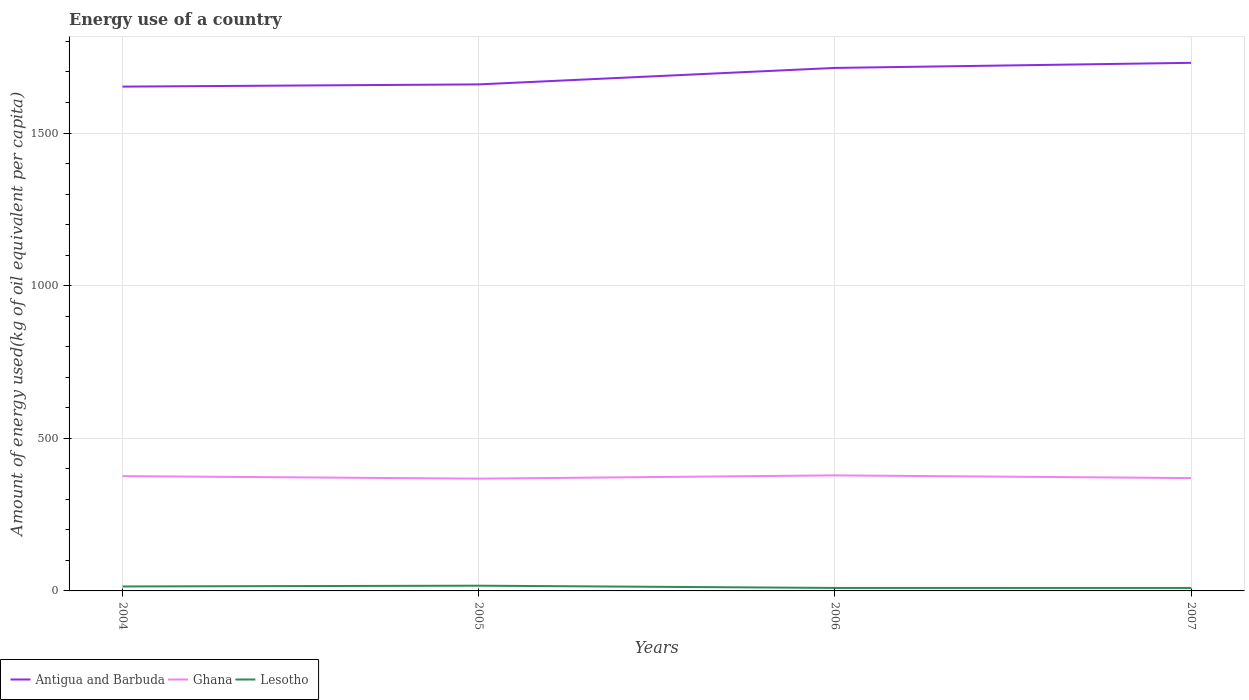Is the number of lines equal to the number of legend labels?
Your answer should be compact. Yes. Across all years, what is the maximum amount of energy used in in Ghana?
Provide a short and direct response. 367.76. What is the total amount of energy used in in Lesotho in the graph?
Your answer should be compact. 7.34. What is the difference between the highest and the second highest amount of energy used in in Antigua and Barbuda?
Make the answer very short. 77.9. How many lines are there?
Make the answer very short. 3. Does the graph contain any zero values?
Your answer should be very brief. No. How many legend labels are there?
Give a very brief answer. 3. What is the title of the graph?
Offer a very short reply. Energy use of a country. Does "Gabon" appear as one of the legend labels in the graph?
Your answer should be very brief. No. What is the label or title of the X-axis?
Offer a terse response. Years. What is the label or title of the Y-axis?
Ensure brevity in your answer.  Amount of energy used(kg of oil equivalent per capita). What is the Amount of energy used(kg of oil equivalent per capita) of Antigua and Barbuda in 2004?
Your response must be concise. 1652.02. What is the Amount of energy used(kg of oil equivalent per capita) of Ghana in 2004?
Offer a very short reply. 376.03. What is the Amount of energy used(kg of oil equivalent per capita) in Lesotho in 2004?
Provide a short and direct response. 14.64. What is the Amount of energy used(kg of oil equivalent per capita) in Antigua and Barbuda in 2005?
Keep it short and to the point. 1659.3. What is the Amount of energy used(kg of oil equivalent per capita) of Ghana in 2005?
Your answer should be compact. 367.76. What is the Amount of energy used(kg of oil equivalent per capita) of Lesotho in 2005?
Offer a terse response. 17.14. What is the Amount of energy used(kg of oil equivalent per capita) of Antigua and Barbuda in 2006?
Make the answer very short. 1713.25. What is the Amount of energy used(kg of oil equivalent per capita) of Ghana in 2006?
Make the answer very short. 378.49. What is the Amount of energy used(kg of oil equivalent per capita) in Lesotho in 2006?
Make the answer very short. 9.79. What is the Amount of energy used(kg of oil equivalent per capita) in Antigua and Barbuda in 2007?
Keep it short and to the point. 1729.92. What is the Amount of energy used(kg of oil equivalent per capita) in Ghana in 2007?
Ensure brevity in your answer.  369.66. What is the Amount of energy used(kg of oil equivalent per capita) in Lesotho in 2007?
Provide a succinct answer. 9.72. Across all years, what is the maximum Amount of energy used(kg of oil equivalent per capita) in Antigua and Barbuda?
Ensure brevity in your answer.  1729.92. Across all years, what is the maximum Amount of energy used(kg of oil equivalent per capita) of Ghana?
Keep it short and to the point. 378.49. Across all years, what is the maximum Amount of energy used(kg of oil equivalent per capita) of Lesotho?
Ensure brevity in your answer.  17.14. Across all years, what is the minimum Amount of energy used(kg of oil equivalent per capita) of Antigua and Barbuda?
Offer a very short reply. 1652.02. Across all years, what is the minimum Amount of energy used(kg of oil equivalent per capita) of Ghana?
Provide a short and direct response. 367.76. Across all years, what is the minimum Amount of energy used(kg of oil equivalent per capita) of Lesotho?
Your answer should be compact. 9.72. What is the total Amount of energy used(kg of oil equivalent per capita) in Antigua and Barbuda in the graph?
Ensure brevity in your answer.  6754.49. What is the total Amount of energy used(kg of oil equivalent per capita) in Ghana in the graph?
Offer a terse response. 1491.93. What is the total Amount of energy used(kg of oil equivalent per capita) of Lesotho in the graph?
Ensure brevity in your answer.  51.29. What is the difference between the Amount of energy used(kg of oil equivalent per capita) of Antigua and Barbuda in 2004 and that in 2005?
Give a very brief answer. -7.28. What is the difference between the Amount of energy used(kg of oil equivalent per capita) of Ghana in 2004 and that in 2005?
Offer a terse response. 8.27. What is the difference between the Amount of energy used(kg of oil equivalent per capita) of Lesotho in 2004 and that in 2005?
Offer a terse response. -2.49. What is the difference between the Amount of energy used(kg of oil equivalent per capita) of Antigua and Barbuda in 2004 and that in 2006?
Ensure brevity in your answer.  -61.23. What is the difference between the Amount of energy used(kg of oil equivalent per capita) of Ghana in 2004 and that in 2006?
Your answer should be compact. -2.46. What is the difference between the Amount of energy used(kg of oil equivalent per capita) of Lesotho in 2004 and that in 2006?
Provide a short and direct response. 4.85. What is the difference between the Amount of energy used(kg of oil equivalent per capita) of Antigua and Barbuda in 2004 and that in 2007?
Make the answer very short. -77.9. What is the difference between the Amount of energy used(kg of oil equivalent per capita) of Ghana in 2004 and that in 2007?
Ensure brevity in your answer.  6.37. What is the difference between the Amount of energy used(kg of oil equivalent per capita) of Lesotho in 2004 and that in 2007?
Ensure brevity in your answer.  4.93. What is the difference between the Amount of energy used(kg of oil equivalent per capita) in Antigua and Barbuda in 2005 and that in 2006?
Provide a short and direct response. -53.95. What is the difference between the Amount of energy used(kg of oil equivalent per capita) in Ghana in 2005 and that in 2006?
Give a very brief answer. -10.73. What is the difference between the Amount of energy used(kg of oil equivalent per capita) of Lesotho in 2005 and that in 2006?
Your answer should be compact. 7.34. What is the difference between the Amount of energy used(kg of oil equivalent per capita) in Antigua and Barbuda in 2005 and that in 2007?
Ensure brevity in your answer.  -70.62. What is the difference between the Amount of energy used(kg of oil equivalent per capita) of Ghana in 2005 and that in 2007?
Give a very brief answer. -1.9. What is the difference between the Amount of energy used(kg of oil equivalent per capita) in Lesotho in 2005 and that in 2007?
Give a very brief answer. 7.42. What is the difference between the Amount of energy used(kg of oil equivalent per capita) of Antigua and Barbuda in 2006 and that in 2007?
Offer a terse response. -16.67. What is the difference between the Amount of energy used(kg of oil equivalent per capita) of Ghana in 2006 and that in 2007?
Make the answer very short. 8.83. What is the difference between the Amount of energy used(kg of oil equivalent per capita) in Lesotho in 2006 and that in 2007?
Give a very brief answer. 0.08. What is the difference between the Amount of energy used(kg of oil equivalent per capita) of Antigua and Barbuda in 2004 and the Amount of energy used(kg of oil equivalent per capita) of Ghana in 2005?
Ensure brevity in your answer.  1284.27. What is the difference between the Amount of energy used(kg of oil equivalent per capita) of Antigua and Barbuda in 2004 and the Amount of energy used(kg of oil equivalent per capita) of Lesotho in 2005?
Make the answer very short. 1634.89. What is the difference between the Amount of energy used(kg of oil equivalent per capita) in Ghana in 2004 and the Amount of energy used(kg of oil equivalent per capita) in Lesotho in 2005?
Provide a succinct answer. 358.89. What is the difference between the Amount of energy used(kg of oil equivalent per capita) in Antigua and Barbuda in 2004 and the Amount of energy used(kg of oil equivalent per capita) in Ghana in 2006?
Your answer should be very brief. 1273.54. What is the difference between the Amount of energy used(kg of oil equivalent per capita) in Antigua and Barbuda in 2004 and the Amount of energy used(kg of oil equivalent per capita) in Lesotho in 2006?
Offer a terse response. 1642.23. What is the difference between the Amount of energy used(kg of oil equivalent per capita) of Ghana in 2004 and the Amount of energy used(kg of oil equivalent per capita) of Lesotho in 2006?
Provide a short and direct response. 366.24. What is the difference between the Amount of energy used(kg of oil equivalent per capita) of Antigua and Barbuda in 2004 and the Amount of energy used(kg of oil equivalent per capita) of Ghana in 2007?
Provide a short and direct response. 1282.37. What is the difference between the Amount of energy used(kg of oil equivalent per capita) in Antigua and Barbuda in 2004 and the Amount of energy used(kg of oil equivalent per capita) in Lesotho in 2007?
Provide a succinct answer. 1642.31. What is the difference between the Amount of energy used(kg of oil equivalent per capita) in Ghana in 2004 and the Amount of energy used(kg of oil equivalent per capita) in Lesotho in 2007?
Make the answer very short. 366.31. What is the difference between the Amount of energy used(kg of oil equivalent per capita) in Antigua and Barbuda in 2005 and the Amount of energy used(kg of oil equivalent per capita) in Ghana in 2006?
Provide a succinct answer. 1280.81. What is the difference between the Amount of energy used(kg of oil equivalent per capita) in Antigua and Barbuda in 2005 and the Amount of energy used(kg of oil equivalent per capita) in Lesotho in 2006?
Provide a short and direct response. 1649.51. What is the difference between the Amount of energy used(kg of oil equivalent per capita) of Ghana in 2005 and the Amount of energy used(kg of oil equivalent per capita) of Lesotho in 2006?
Your answer should be very brief. 357.97. What is the difference between the Amount of energy used(kg of oil equivalent per capita) of Antigua and Barbuda in 2005 and the Amount of energy used(kg of oil equivalent per capita) of Ghana in 2007?
Make the answer very short. 1289.64. What is the difference between the Amount of energy used(kg of oil equivalent per capita) of Antigua and Barbuda in 2005 and the Amount of energy used(kg of oil equivalent per capita) of Lesotho in 2007?
Offer a terse response. 1649.58. What is the difference between the Amount of energy used(kg of oil equivalent per capita) of Ghana in 2005 and the Amount of energy used(kg of oil equivalent per capita) of Lesotho in 2007?
Make the answer very short. 358.04. What is the difference between the Amount of energy used(kg of oil equivalent per capita) of Antigua and Barbuda in 2006 and the Amount of energy used(kg of oil equivalent per capita) of Ghana in 2007?
Give a very brief answer. 1343.59. What is the difference between the Amount of energy used(kg of oil equivalent per capita) of Antigua and Barbuda in 2006 and the Amount of energy used(kg of oil equivalent per capita) of Lesotho in 2007?
Your answer should be very brief. 1703.54. What is the difference between the Amount of energy used(kg of oil equivalent per capita) in Ghana in 2006 and the Amount of energy used(kg of oil equivalent per capita) in Lesotho in 2007?
Ensure brevity in your answer.  368.77. What is the average Amount of energy used(kg of oil equivalent per capita) of Antigua and Barbuda per year?
Keep it short and to the point. 1688.62. What is the average Amount of energy used(kg of oil equivalent per capita) in Ghana per year?
Offer a terse response. 372.98. What is the average Amount of energy used(kg of oil equivalent per capita) of Lesotho per year?
Give a very brief answer. 12.82. In the year 2004, what is the difference between the Amount of energy used(kg of oil equivalent per capita) of Antigua and Barbuda and Amount of energy used(kg of oil equivalent per capita) of Ghana?
Offer a very short reply. 1275.99. In the year 2004, what is the difference between the Amount of energy used(kg of oil equivalent per capita) in Antigua and Barbuda and Amount of energy used(kg of oil equivalent per capita) in Lesotho?
Give a very brief answer. 1637.38. In the year 2004, what is the difference between the Amount of energy used(kg of oil equivalent per capita) of Ghana and Amount of energy used(kg of oil equivalent per capita) of Lesotho?
Keep it short and to the point. 361.38. In the year 2005, what is the difference between the Amount of energy used(kg of oil equivalent per capita) in Antigua and Barbuda and Amount of energy used(kg of oil equivalent per capita) in Ghana?
Ensure brevity in your answer.  1291.54. In the year 2005, what is the difference between the Amount of energy used(kg of oil equivalent per capita) in Antigua and Barbuda and Amount of energy used(kg of oil equivalent per capita) in Lesotho?
Your answer should be compact. 1642.16. In the year 2005, what is the difference between the Amount of energy used(kg of oil equivalent per capita) in Ghana and Amount of energy used(kg of oil equivalent per capita) in Lesotho?
Your answer should be compact. 350.62. In the year 2006, what is the difference between the Amount of energy used(kg of oil equivalent per capita) of Antigua and Barbuda and Amount of energy used(kg of oil equivalent per capita) of Ghana?
Your response must be concise. 1334.77. In the year 2006, what is the difference between the Amount of energy used(kg of oil equivalent per capita) in Antigua and Barbuda and Amount of energy used(kg of oil equivalent per capita) in Lesotho?
Provide a short and direct response. 1703.46. In the year 2006, what is the difference between the Amount of energy used(kg of oil equivalent per capita) of Ghana and Amount of energy used(kg of oil equivalent per capita) of Lesotho?
Your answer should be compact. 368.69. In the year 2007, what is the difference between the Amount of energy used(kg of oil equivalent per capita) of Antigua and Barbuda and Amount of energy used(kg of oil equivalent per capita) of Ghana?
Offer a terse response. 1360.26. In the year 2007, what is the difference between the Amount of energy used(kg of oil equivalent per capita) of Antigua and Barbuda and Amount of energy used(kg of oil equivalent per capita) of Lesotho?
Offer a very short reply. 1720.2. In the year 2007, what is the difference between the Amount of energy used(kg of oil equivalent per capita) of Ghana and Amount of energy used(kg of oil equivalent per capita) of Lesotho?
Offer a very short reply. 359.94. What is the ratio of the Amount of energy used(kg of oil equivalent per capita) of Ghana in 2004 to that in 2005?
Provide a short and direct response. 1.02. What is the ratio of the Amount of energy used(kg of oil equivalent per capita) in Lesotho in 2004 to that in 2005?
Ensure brevity in your answer.  0.85. What is the ratio of the Amount of energy used(kg of oil equivalent per capita) of Ghana in 2004 to that in 2006?
Your response must be concise. 0.99. What is the ratio of the Amount of energy used(kg of oil equivalent per capita) of Lesotho in 2004 to that in 2006?
Give a very brief answer. 1.5. What is the ratio of the Amount of energy used(kg of oil equivalent per capita) in Antigua and Barbuda in 2004 to that in 2007?
Keep it short and to the point. 0.95. What is the ratio of the Amount of energy used(kg of oil equivalent per capita) in Ghana in 2004 to that in 2007?
Keep it short and to the point. 1.02. What is the ratio of the Amount of energy used(kg of oil equivalent per capita) of Lesotho in 2004 to that in 2007?
Provide a succinct answer. 1.51. What is the ratio of the Amount of energy used(kg of oil equivalent per capita) of Antigua and Barbuda in 2005 to that in 2006?
Keep it short and to the point. 0.97. What is the ratio of the Amount of energy used(kg of oil equivalent per capita) in Ghana in 2005 to that in 2006?
Ensure brevity in your answer.  0.97. What is the ratio of the Amount of energy used(kg of oil equivalent per capita) of Lesotho in 2005 to that in 2006?
Make the answer very short. 1.75. What is the ratio of the Amount of energy used(kg of oil equivalent per capita) of Antigua and Barbuda in 2005 to that in 2007?
Your response must be concise. 0.96. What is the ratio of the Amount of energy used(kg of oil equivalent per capita) of Ghana in 2005 to that in 2007?
Offer a terse response. 0.99. What is the ratio of the Amount of energy used(kg of oil equivalent per capita) in Lesotho in 2005 to that in 2007?
Your answer should be compact. 1.76. What is the ratio of the Amount of energy used(kg of oil equivalent per capita) of Antigua and Barbuda in 2006 to that in 2007?
Your answer should be compact. 0.99. What is the ratio of the Amount of energy used(kg of oil equivalent per capita) in Ghana in 2006 to that in 2007?
Provide a succinct answer. 1.02. What is the ratio of the Amount of energy used(kg of oil equivalent per capita) in Lesotho in 2006 to that in 2007?
Provide a succinct answer. 1.01. What is the difference between the highest and the second highest Amount of energy used(kg of oil equivalent per capita) in Antigua and Barbuda?
Keep it short and to the point. 16.67. What is the difference between the highest and the second highest Amount of energy used(kg of oil equivalent per capita) in Ghana?
Give a very brief answer. 2.46. What is the difference between the highest and the second highest Amount of energy used(kg of oil equivalent per capita) of Lesotho?
Give a very brief answer. 2.49. What is the difference between the highest and the lowest Amount of energy used(kg of oil equivalent per capita) of Antigua and Barbuda?
Your response must be concise. 77.9. What is the difference between the highest and the lowest Amount of energy used(kg of oil equivalent per capita) in Ghana?
Give a very brief answer. 10.73. What is the difference between the highest and the lowest Amount of energy used(kg of oil equivalent per capita) of Lesotho?
Your answer should be compact. 7.42. 